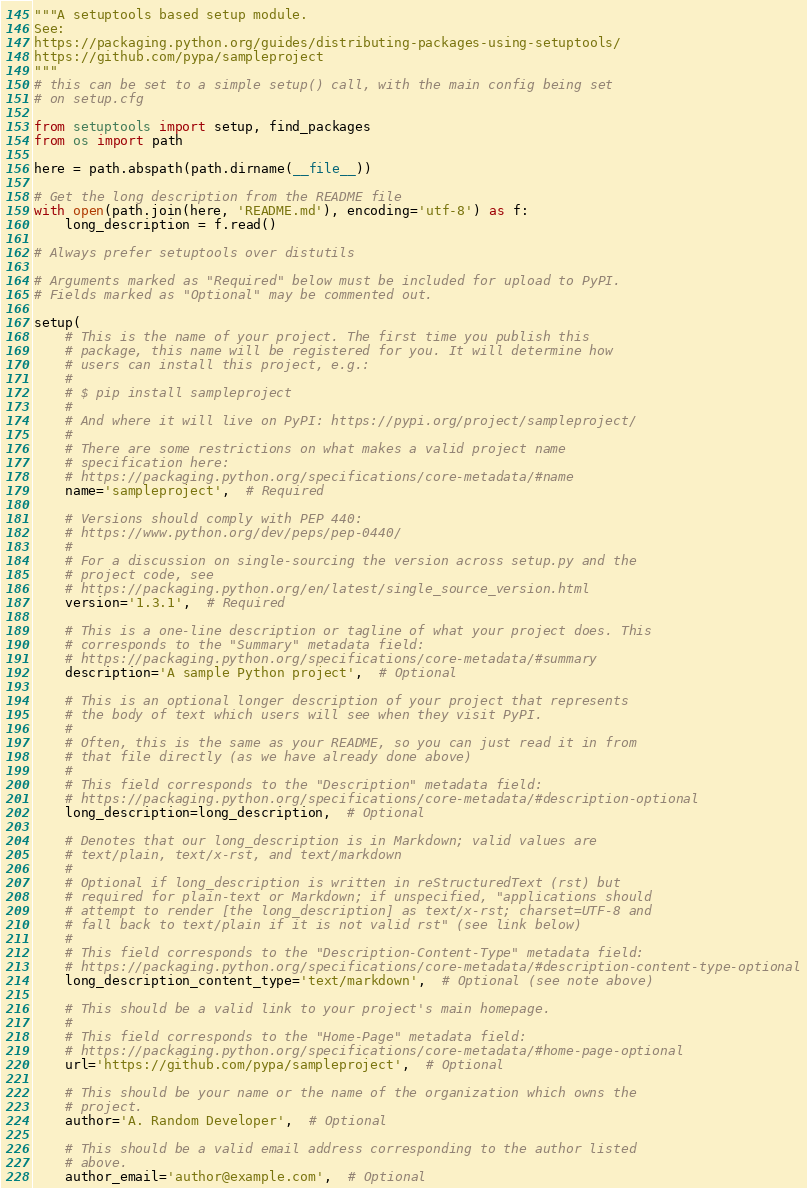<code> <loc_0><loc_0><loc_500><loc_500><_Python_>"""A setuptools based setup module.
See:
https://packaging.python.org/guides/distributing-packages-using-setuptools/
https://github.com/pypa/sampleproject
"""
# this can be set to a simple setup() call, with the main config being set 
# on setup.cfg

from setuptools import setup, find_packages
from os import path

here = path.abspath(path.dirname(__file__))

# Get the long description from the README file
with open(path.join(here, 'README.md'), encoding='utf-8') as f:
    long_description = f.read()

# Always prefer setuptools over distutils

# Arguments marked as "Required" below must be included for upload to PyPI.
# Fields marked as "Optional" may be commented out.

setup(
    # This is the name of your project. The first time you publish this
    # package, this name will be registered for you. It will determine how
    # users can install this project, e.g.:
    #
    # $ pip install sampleproject
    #
    # And where it will live on PyPI: https://pypi.org/project/sampleproject/
    #
    # There are some restrictions on what makes a valid project name
    # specification here:
    # https://packaging.python.org/specifications/core-metadata/#name
    name='sampleproject',  # Required

    # Versions should comply with PEP 440:
    # https://www.python.org/dev/peps/pep-0440/
    #
    # For a discussion on single-sourcing the version across setup.py and the
    # project code, see
    # https://packaging.python.org/en/latest/single_source_version.html
    version='1.3.1',  # Required

    # This is a one-line description or tagline of what your project does. This
    # corresponds to the "Summary" metadata field:
    # https://packaging.python.org/specifications/core-metadata/#summary
    description='A sample Python project',  # Optional

    # This is an optional longer description of your project that represents
    # the body of text which users will see when they visit PyPI.
    #
    # Often, this is the same as your README, so you can just read it in from
    # that file directly (as we have already done above)
    #
    # This field corresponds to the "Description" metadata field:
    # https://packaging.python.org/specifications/core-metadata/#description-optional
    long_description=long_description,  # Optional

    # Denotes that our long_description is in Markdown; valid values are
    # text/plain, text/x-rst, and text/markdown
    #
    # Optional if long_description is written in reStructuredText (rst) but
    # required for plain-text or Markdown; if unspecified, "applications should
    # attempt to render [the long_description] as text/x-rst; charset=UTF-8 and
    # fall back to text/plain if it is not valid rst" (see link below)
    #
    # This field corresponds to the "Description-Content-Type" metadata field:
    # https://packaging.python.org/specifications/core-metadata/#description-content-type-optional
    long_description_content_type='text/markdown',  # Optional (see note above)

    # This should be a valid link to your project's main homepage.
    #
    # This field corresponds to the "Home-Page" metadata field:
    # https://packaging.python.org/specifications/core-metadata/#home-page-optional
    url='https://github.com/pypa/sampleproject',  # Optional

    # This should be your name or the name of the organization which owns the
    # project.
    author='A. Random Developer',  # Optional

    # This should be a valid email address corresponding to the author listed
    # above.
    author_email='author@example.com',  # Optional
</code> 